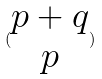Convert formula to latex. <formula><loc_0><loc_0><loc_500><loc_500>( \begin{matrix} p + q \\ p \end{matrix} )</formula> 